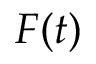Convert formula to latex. <formula><loc_0><loc_0><loc_500><loc_500>F ( t )</formula> 